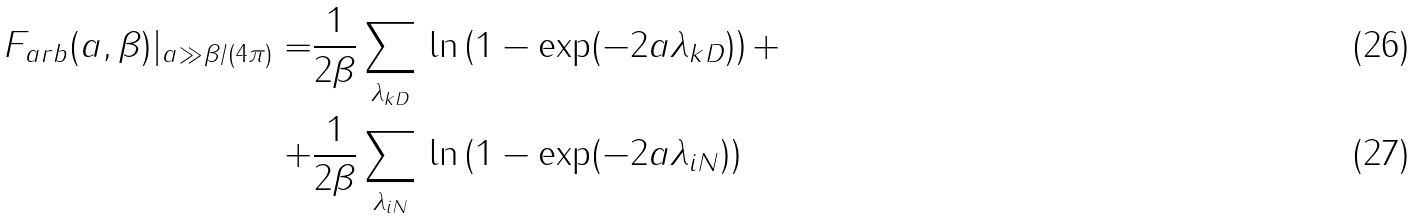Convert formula to latex. <formula><loc_0><loc_0><loc_500><loc_500>F _ { a r b } ( a , \beta ) | _ { a \gg \beta / ( 4 \pi ) } = & \frac { 1 } { 2 \beta } \sum _ { \lambda _ { k D } } \, \ln \left ( 1 - \exp ( - 2 a \lambda _ { k D } ) \right ) + \\ + & \frac { 1 } { 2 \beta } \sum _ { \lambda _ { i N } } \, \ln \left ( 1 - \exp ( - 2 a \lambda _ { i N } ) \right )</formula> 